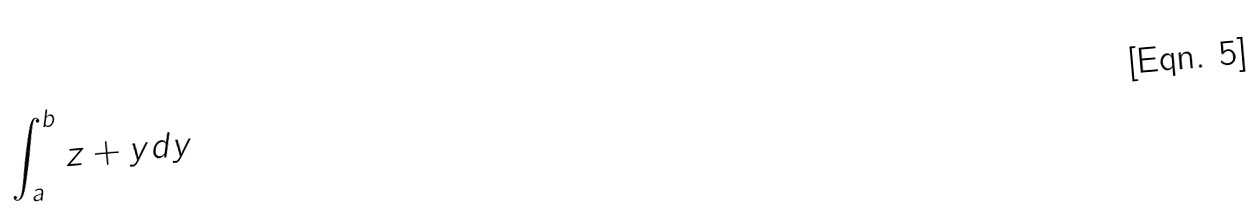Convert formula to latex. <formula><loc_0><loc_0><loc_500><loc_500>\int _ { a } ^ { b } z + y d y</formula> 